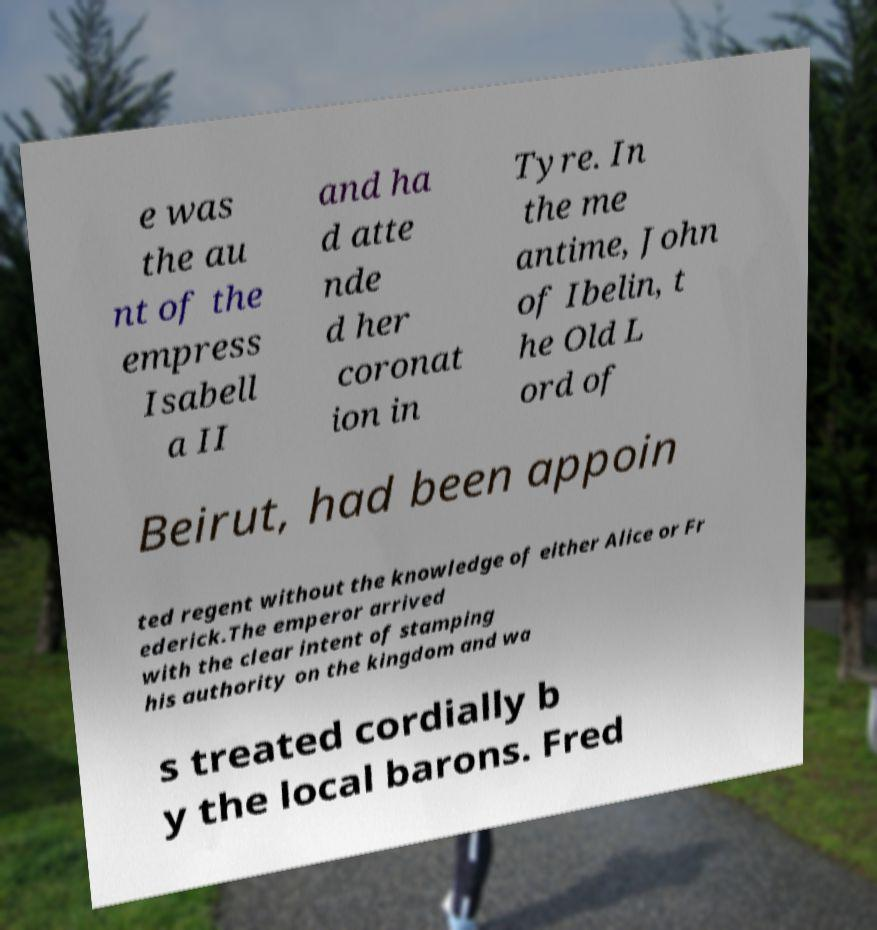Could you extract and type out the text from this image? e was the au nt of the empress Isabell a II and ha d atte nde d her coronat ion in Tyre. In the me antime, John of Ibelin, t he Old L ord of Beirut, had been appoin ted regent without the knowledge of either Alice or Fr ederick.The emperor arrived with the clear intent of stamping his authority on the kingdom and wa s treated cordially b y the local barons. Fred 